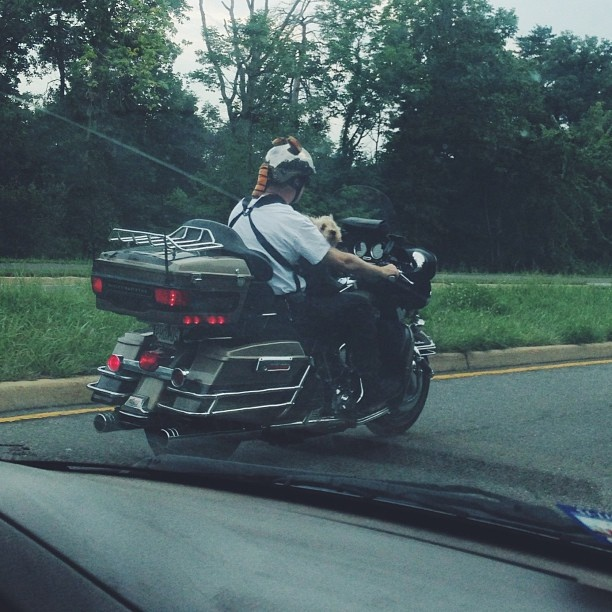Describe the objects in this image and their specific colors. I can see car in black and gray tones, motorcycle in black, purple, and gray tones, people in black, darkblue, gray, and blue tones, suitcase in black, purple, and teal tones, and dog in black, darkgray, gray, and purple tones in this image. 